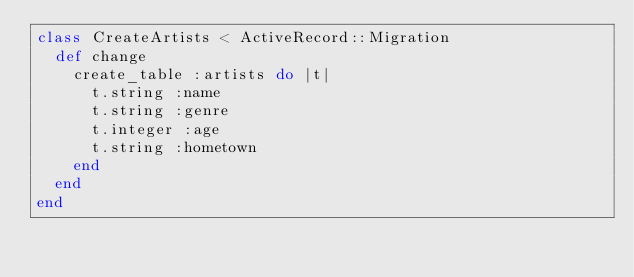Convert code to text. <code><loc_0><loc_0><loc_500><loc_500><_Ruby_>class CreateArtists < ActiveRecord::Migration
  def change
    create_table :artists do |t|
      t.string :name
      t.string :genre
      t.integer :age
      t.string :hometown
    end
  end
end 
</code> 